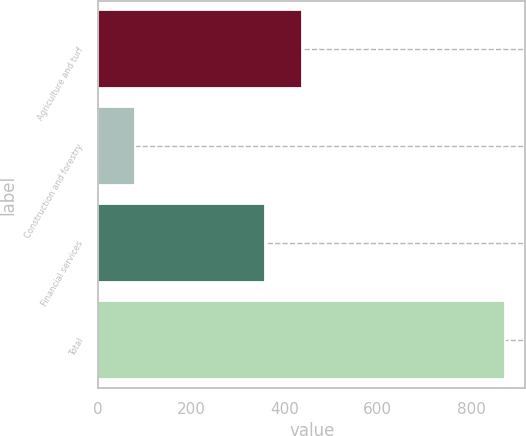Convert chart to OTSL. <chart><loc_0><loc_0><loc_500><loc_500><bar_chart><fcel>Agriculture and turf<fcel>Construction and forestry<fcel>Financial services<fcel>Total<nl><fcel>438<fcel>78<fcel>357<fcel>873<nl></chart> 